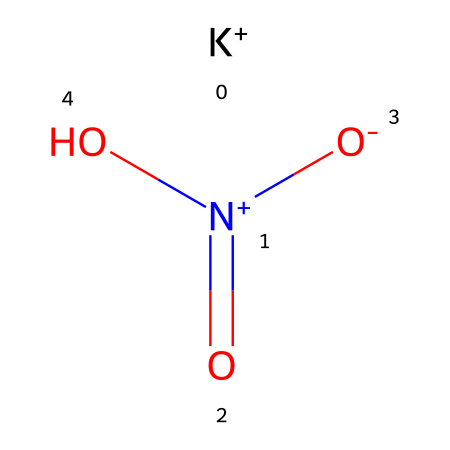What is the formula for this compound? The SMILES representation shows the components of the molecule, which include one potassium (K) atom, one nitrogen (N) atom, and three oxygen (O) atoms. The chemical formula is based on the elemental composition identified.
Answer: KNO3 How many oxygen atoms are in this molecule? The SMILES representation indicates that there are three oxygen (O) atoms present in the molecular structure, as denoted by the three 'O' notations within the chemical.
Answer: 3 Which element provides the preservative properties in this chemical? The nitrogen atom in the compound is the key element that contributes to the preservative properties, particularly with its role in forming nitrate, which inhibits microbial growth.
Answer: nitrogen What type of ion does potassium nitrate dissociate into in solution? The chemical dissociates in solution to form potassium ions (K+) and nitrate ions (NO3-), as indicated by the presence of the K+ label and the nitrogen-oxygen configuration in the SMILES representation.
Answer: potassium and nitrate ions How does this compound interact with microbial growth? The nitrate component of potassium nitrate interferes with the metabolic processes of many bacteria, effectively inhibiting their growth by restricting their ability to thrive, due to the presence of the nitrogen in the form of nitrate.
Answer: inhibits microbial growth What is the oxidation state of nitrogen in this compound? By evaluating the bonds and the overall charge balance in potassium nitrate, it can be determined that nitrogen has an oxidation state of +5, as indicated by the arrangement of bonds in the SMILES notation where nitrogen is double bonded to two oxygens and single bonded to one.
Answer: +5 